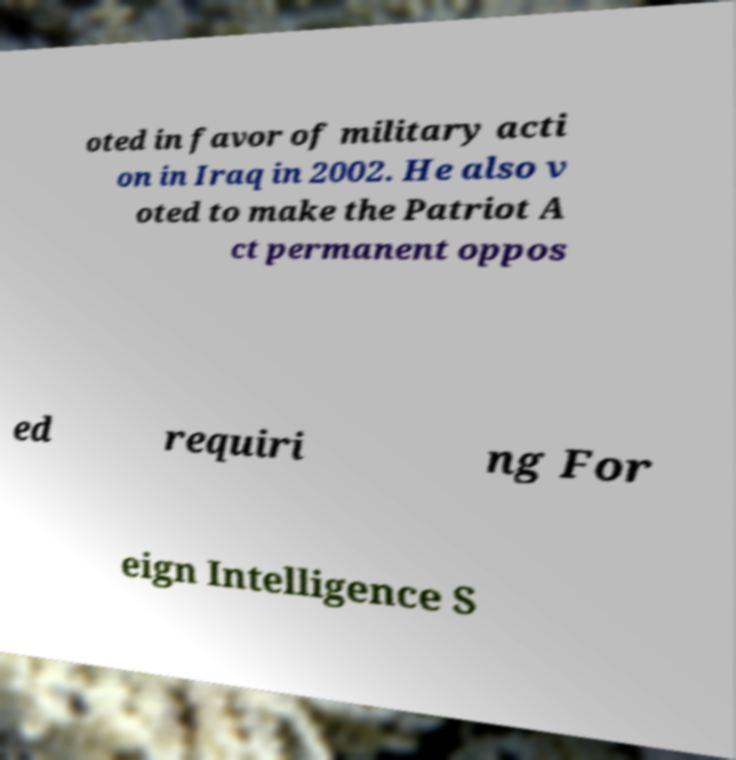For documentation purposes, I need the text within this image transcribed. Could you provide that? oted in favor of military acti on in Iraq in 2002. He also v oted to make the Patriot A ct permanent oppos ed requiri ng For eign Intelligence S 